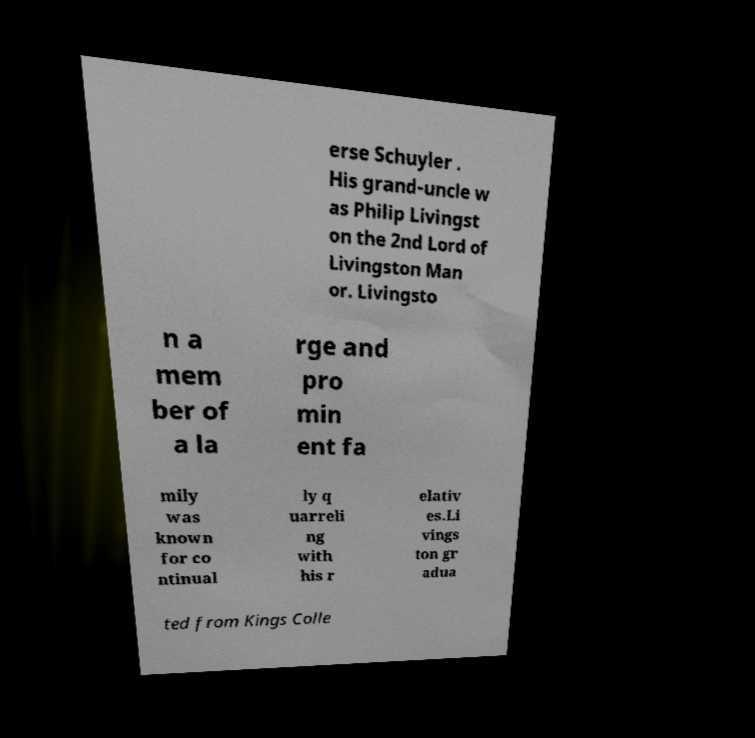I need the written content from this picture converted into text. Can you do that? erse Schuyler . His grand-uncle w as Philip Livingst on the 2nd Lord of Livingston Man or. Livingsto n a mem ber of a la rge and pro min ent fa mily was known for co ntinual ly q uarreli ng with his r elativ es.Li vings ton gr adua ted from Kings Colle 